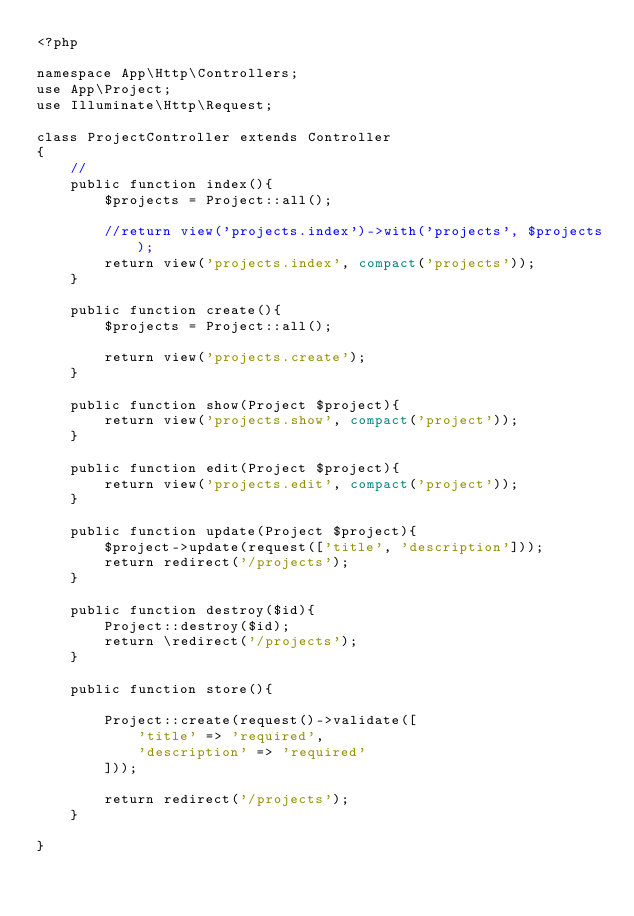<code> <loc_0><loc_0><loc_500><loc_500><_PHP_><?php

namespace App\Http\Controllers;
use App\Project;
use Illuminate\Http\Request;

class ProjectController extends Controller
{
    //
    public function index(){
        $projects = Project::all();

        //return view('projects.index')->with('projects', $projects);
        return view('projects.index', compact('projects'));
    }
    
    public function create(){
        $projects = Project::all();

        return view('projects.create');
    }
    
    public function show(Project $project){
        return view('projects.show', compact('project'));
    }
    
    public function edit(Project $project){
        return view('projects.edit', compact('project'));
    }
    
    public function update(Project $project){
        $project->update(request(['title', 'description']));
        return redirect('/projects');
    }
    
    public function destroy($id){
        Project::destroy($id);
        return \redirect('/projects'); 
    }
    
    public function store(){

        Project::create(request()->validate([
            'title' => 'required',
            'description' => 'required'
        ]));

        return redirect('/projects');
    }

}
</code> 